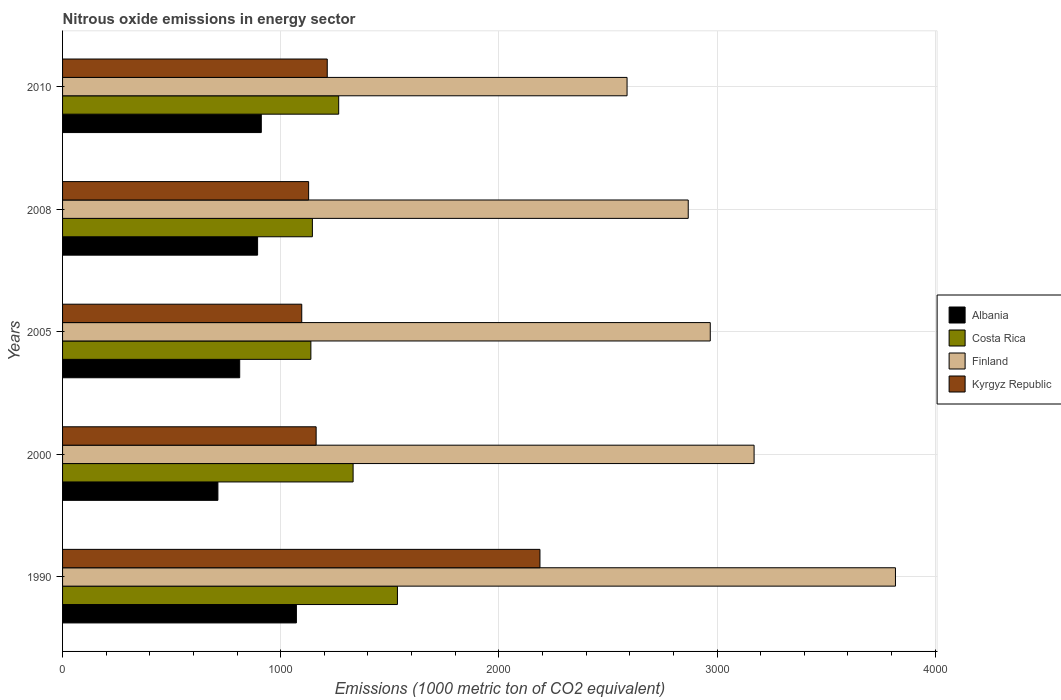How many groups of bars are there?
Provide a succinct answer. 5. How many bars are there on the 3rd tick from the bottom?
Offer a very short reply. 4. What is the amount of nitrous oxide emitted in Finland in 2010?
Ensure brevity in your answer.  2587.6. Across all years, what is the maximum amount of nitrous oxide emitted in Finland?
Your response must be concise. 3817.9. Across all years, what is the minimum amount of nitrous oxide emitted in Costa Rica?
Give a very brief answer. 1138.2. What is the total amount of nitrous oxide emitted in Albania in the graph?
Your response must be concise. 4401. What is the difference between the amount of nitrous oxide emitted in Albania in 2008 and that in 2010?
Provide a succinct answer. -17. What is the difference between the amount of nitrous oxide emitted in Finland in 2010 and the amount of nitrous oxide emitted in Kyrgyz Republic in 2005?
Offer a terse response. 1491.2. What is the average amount of nitrous oxide emitted in Albania per year?
Offer a very short reply. 880.2. In the year 2008, what is the difference between the amount of nitrous oxide emitted in Finland and amount of nitrous oxide emitted in Kyrgyz Republic?
Your response must be concise. 1740.1. In how many years, is the amount of nitrous oxide emitted in Kyrgyz Republic greater than 2000 1000 metric ton?
Your response must be concise. 1. What is the ratio of the amount of nitrous oxide emitted in Finland in 1990 to that in 2010?
Your answer should be very brief. 1.48. Is the amount of nitrous oxide emitted in Kyrgyz Republic in 2005 less than that in 2010?
Offer a very short reply. Yes. Is the difference between the amount of nitrous oxide emitted in Finland in 1990 and 2008 greater than the difference between the amount of nitrous oxide emitted in Kyrgyz Republic in 1990 and 2008?
Your response must be concise. No. What is the difference between the highest and the second highest amount of nitrous oxide emitted in Kyrgyz Republic?
Your response must be concise. 975. What is the difference between the highest and the lowest amount of nitrous oxide emitted in Albania?
Give a very brief answer. 359.8. In how many years, is the amount of nitrous oxide emitted in Finland greater than the average amount of nitrous oxide emitted in Finland taken over all years?
Offer a terse response. 2. Is it the case that in every year, the sum of the amount of nitrous oxide emitted in Costa Rica and amount of nitrous oxide emitted in Finland is greater than the sum of amount of nitrous oxide emitted in Kyrgyz Republic and amount of nitrous oxide emitted in Albania?
Offer a very short reply. Yes. What does the 2nd bar from the bottom in 2008 represents?
Provide a succinct answer. Costa Rica. How many bars are there?
Your answer should be compact. 20. Are all the bars in the graph horizontal?
Offer a very short reply. Yes. How many years are there in the graph?
Provide a short and direct response. 5. What is the difference between two consecutive major ticks on the X-axis?
Provide a succinct answer. 1000. Are the values on the major ticks of X-axis written in scientific E-notation?
Your response must be concise. No. Where does the legend appear in the graph?
Offer a very short reply. Center right. What is the title of the graph?
Offer a terse response. Nitrous oxide emissions in energy sector. What is the label or title of the X-axis?
Your response must be concise. Emissions (1000 metric ton of CO2 equivalent). What is the label or title of the Y-axis?
Your answer should be compact. Years. What is the Emissions (1000 metric ton of CO2 equivalent) of Albania in 1990?
Offer a terse response. 1071.9. What is the Emissions (1000 metric ton of CO2 equivalent) in Costa Rica in 1990?
Your response must be concise. 1535. What is the Emissions (1000 metric ton of CO2 equivalent) in Finland in 1990?
Provide a succinct answer. 3817.9. What is the Emissions (1000 metric ton of CO2 equivalent) of Kyrgyz Republic in 1990?
Your answer should be compact. 2188.3. What is the Emissions (1000 metric ton of CO2 equivalent) of Albania in 2000?
Ensure brevity in your answer.  712.1. What is the Emissions (1000 metric ton of CO2 equivalent) in Costa Rica in 2000?
Provide a short and direct response. 1331.8. What is the Emissions (1000 metric ton of CO2 equivalent) in Finland in 2000?
Your answer should be very brief. 3169.9. What is the Emissions (1000 metric ton of CO2 equivalent) of Kyrgyz Republic in 2000?
Provide a succinct answer. 1162.4. What is the Emissions (1000 metric ton of CO2 equivalent) in Albania in 2005?
Keep it short and to the point. 812. What is the Emissions (1000 metric ton of CO2 equivalent) in Costa Rica in 2005?
Give a very brief answer. 1138.2. What is the Emissions (1000 metric ton of CO2 equivalent) in Finland in 2005?
Give a very brief answer. 2969. What is the Emissions (1000 metric ton of CO2 equivalent) in Kyrgyz Republic in 2005?
Your answer should be compact. 1096.4. What is the Emissions (1000 metric ton of CO2 equivalent) in Albania in 2008?
Make the answer very short. 894. What is the Emissions (1000 metric ton of CO2 equivalent) of Costa Rica in 2008?
Give a very brief answer. 1145.2. What is the Emissions (1000 metric ton of CO2 equivalent) in Finland in 2008?
Your answer should be very brief. 2868. What is the Emissions (1000 metric ton of CO2 equivalent) in Kyrgyz Republic in 2008?
Provide a succinct answer. 1127.9. What is the Emissions (1000 metric ton of CO2 equivalent) of Albania in 2010?
Make the answer very short. 911. What is the Emissions (1000 metric ton of CO2 equivalent) in Costa Rica in 2010?
Your answer should be very brief. 1265.7. What is the Emissions (1000 metric ton of CO2 equivalent) of Finland in 2010?
Offer a terse response. 2587.6. What is the Emissions (1000 metric ton of CO2 equivalent) in Kyrgyz Republic in 2010?
Offer a terse response. 1213.3. Across all years, what is the maximum Emissions (1000 metric ton of CO2 equivalent) of Albania?
Provide a short and direct response. 1071.9. Across all years, what is the maximum Emissions (1000 metric ton of CO2 equivalent) in Costa Rica?
Ensure brevity in your answer.  1535. Across all years, what is the maximum Emissions (1000 metric ton of CO2 equivalent) in Finland?
Provide a succinct answer. 3817.9. Across all years, what is the maximum Emissions (1000 metric ton of CO2 equivalent) of Kyrgyz Republic?
Your answer should be compact. 2188.3. Across all years, what is the minimum Emissions (1000 metric ton of CO2 equivalent) of Albania?
Give a very brief answer. 712.1. Across all years, what is the minimum Emissions (1000 metric ton of CO2 equivalent) in Costa Rica?
Keep it short and to the point. 1138.2. Across all years, what is the minimum Emissions (1000 metric ton of CO2 equivalent) of Finland?
Offer a very short reply. 2587.6. Across all years, what is the minimum Emissions (1000 metric ton of CO2 equivalent) of Kyrgyz Republic?
Your answer should be very brief. 1096.4. What is the total Emissions (1000 metric ton of CO2 equivalent) in Albania in the graph?
Offer a terse response. 4401. What is the total Emissions (1000 metric ton of CO2 equivalent) in Costa Rica in the graph?
Provide a succinct answer. 6415.9. What is the total Emissions (1000 metric ton of CO2 equivalent) of Finland in the graph?
Your answer should be compact. 1.54e+04. What is the total Emissions (1000 metric ton of CO2 equivalent) of Kyrgyz Republic in the graph?
Your answer should be compact. 6788.3. What is the difference between the Emissions (1000 metric ton of CO2 equivalent) in Albania in 1990 and that in 2000?
Provide a succinct answer. 359.8. What is the difference between the Emissions (1000 metric ton of CO2 equivalent) of Costa Rica in 1990 and that in 2000?
Offer a terse response. 203.2. What is the difference between the Emissions (1000 metric ton of CO2 equivalent) of Finland in 1990 and that in 2000?
Provide a short and direct response. 648. What is the difference between the Emissions (1000 metric ton of CO2 equivalent) in Kyrgyz Republic in 1990 and that in 2000?
Ensure brevity in your answer.  1025.9. What is the difference between the Emissions (1000 metric ton of CO2 equivalent) of Albania in 1990 and that in 2005?
Give a very brief answer. 259.9. What is the difference between the Emissions (1000 metric ton of CO2 equivalent) in Costa Rica in 1990 and that in 2005?
Keep it short and to the point. 396.8. What is the difference between the Emissions (1000 metric ton of CO2 equivalent) in Finland in 1990 and that in 2005?
Your answer should be very brief. 848.9. What is the difference between the Emissions (1000 metric ton of CO2 equivalent) in Kyrgyz Republic in 1990 and that in 2005?
Keep it short and to the point. 1091.9. What is the difference between the Emissions (1000 metric ton of CO2 equivalent) in Albania in 1990 and that in 2008?
Give a very brief answer. 177.9. What is the difference between the Emissions (1000 metric ton of CO2 equivalent) in Costa Rica in 1990 and that in 2008?
Offer a terse response. 389.8. What is the difference between the Emissions (1000 metric ton of CO2 equivalent) of Finland in 1990 and that in 2008?
Keep it short and to the point. 949.9. What is the difference between the Emissions (1000 metric ton of CO2 equivalent) of Kyrgyz Republic in 1990 and that in 2008?
Give a very brief answer. 1060.4. What is the difference between the Emissions (1000 metric ton of CO2 equivalent) in Albania in 1990 and that in 2010?
Give a very brief answer. 160.9. What is the difference between the Emissions (1000 metric ton of CO2 equivalent) of Costa Rica in 1990 and that in 2010?
Keep it short and to the point. 269.3. What is the difference between the Emissions (1000 metric ton of CO2 equivalent) in Finland in 1990 and that in 2010?
Offer a terse response. 1230.3. What is the difference between the Emissions (1000 metric ton of CO2 equivalent) in Kyrgyz Republic in 1990 and that in 2010?
Make the answer very short. 975. What is the difference between the Emissions (1000 metric ton of CO2 equivalent) of Albania in 2000 and that in 2005?
Your answer should be very brief. -99.9. What is the difference between the Emissions (1000 metric ton of CO2 equivalent) of Costa Rica in 2000 and that in 2005?
Give a very brief answer. 193.6. What is the difference between the Emissions (1000 metric ton of CO2 equivalent) in Finland in 2000 and that in 2005?
Keep it short and to the point. 200.9. What is the difference between the Emissions (1000 metric ton of CO2 equivalent) in Albania in 2000 and that in 2008?
Ensure brevity in your answer.  -181.9. What is the difference between the Emissions (1000 metric ton of CO2 equivalent) of Costa Rica in 2000 and that in 2008?
Offer a very short reply. 186.6. What is the difference between the Emissions (1000 metric ton of CO2 equivalent) of Finland in 2000 and that in 2008?
Your answer should be compact. 301.9. What is the difference between the Emissions (1000 metric ton of CO2 equivalent) in Kyrgyz Republic in 2000 and that in 2008?
Offer a terse response. 34.5. What is the difference between the Emissions (1000 metric ton of CO2 equivalent) in Albania in 2000 and that in 2010?
Your answer should be compact. -198.9. What is the difference between the Emissions (1000 metric ton of CO2 equivalent) of Costa Rica in 2000 and that in 2010?
Your response must be concise. 66.1. What is the difference between the Emissions (1000 metric ton of CO2 equivalent) of Finland in 2000 and that in 2010?
Your answer should be compact. 582.3. What is the difference between the Emissions (1000 metric ton of CO2 equivalent) of Kyrgyz Republic in 2000 and that in 2010?
Offer a very short reply. -50.9. What is the difference between the Emissions (1000 metric ton of CO2 equivalent) of Albania in 2005 and that in 2008?
Your response must be concise. -82. What is the difference between the Emissions (1000 metric ton of CO2 equivalent) of Finland in 2005 and that in 2008?
Your answer should be compact. 101. What is the difference between the Emissions (1000 metric ton of CO2 equivalent) of Kyrgyz Republic in 2005 and that in 2008?
Ensure brevity in your answer.  -31.5. What is the difference between the Emissions (1000 metric ton of CO2 equivalent) of Albania in 2005 and that in 2010?
Give a very brief answer. -99. What is the difference between the Emissions (1000 metric ton of CO2 equivalent) in Costa Rica in 2005 and that in 2010?
Your answer should be compact. -127.5. What is the difference between the Emissions (1000 metric ton of CO2 equivalent) of Finland in 2005 and that in 2010?
Ensure brevity in your answer.  381.4. What is the difference between the Emissions (1000 metric ton of CO2 equivalent) in Kyrgyz Republic in 2005 and that in 2010?
Give a very brief answer. -116.9. What is the difference between the Emissions (1000 metric ton of CO2 equivalent) in Costa Rica in 2008 and that in 2010?
Provide a succinct answer. -120.5. What is the difference between the Emissions (1000 metric ton of CO2 equivalent) in Finland in 2008 and that in 2010?
Offer a very short reply. 280.4. What is the difference between the Emissions (1000 metric ton of CO2 equivalent) of Kyrgyz Republic in 2008 and that in 2010?
Offer a very short reply. -85.4. What is the difference between the Emissions (1000 metric ton of CO2 equivalent) of Albania in 1990 and the Emissions (1000 metric ton of CO2 equivalent) of Costa Rica in 2000?
Provide a short and direct response. -259.9. What is the difference between the Emissions (1000 metric ton of CO2 equivalent) in Albania in 1990 and the Emissions (1000 metric ton of CO2 equivalent) in Finland in 2000?
Keep it short and to the point. -2098. What is the difference between the Emissions (1000 metric ton of CO2 equivalent) in Albania in 1990 and the Emissions (1000 metric ton of CO2 equivalent) in Kyrgyz Republic in 2000?
Your response must be concise. -90.5. What is the difference between the Emissions (1000 metric ton of CO2 equivalent) of Costa Rica in 1990 and the Emissions (1000 metric ton of CO2 equivalent) of Finland in 2000?
Your answer should be very brief. -1634.9. What is the difference between the Emissions (1000 metric ton of CO2 equivalent) of Costa Rica in 1990 and the Emissions (1000 metric ton of CO2 equivalent) of Kyrgyz Republic in 2000?
Your response must be concise. 372.6. What is the difference between the Emissions (1000 metric ton of CO2 equivalent) of Finland in 1990 and the Emissions (1000 metric ton of CO2 equivalent) of Kyrgyz Republic in 2000?
Provide a succinct answer. 2655.5. What is the difference between the Emissions (1000 metric ton of CO2 equivalent) of Albania in 1990 and the Emissions (1000 metric ton of CO2 equivalent) of Costa Rica in 2005?
Offer a terse response. -66.3. What is the difference between the Emissions (1000 metric ton of CO2 equivalent) of Albania in 1990 and the Emissions (1000 metric ton of CO2 equivalent) of Finland in 2005?
Give a very brief answer. -1897.1. What is the difference between the Emissions (1000 metric ton of CO2 equivalent) in Albania in 1990 and the Emissions (1000 metric ton of CO2 equivalent) in Kyrgyz Republic in 2005?
Offer a terse response. -24.5. What is the difference between the Emissions (1000 metric ton of CO2 equivalent) in Costa Rica in 1990 and the Emissions (1000 metric ton of CO2 equivalent) in Finland in 2005?
Your answer should be very brief. -1434. What is the difference between the Emissions (1000 metric ton of CO2 equivalent) in Costa Rica in 1990 and the Emissions (1000 metric ton of CO2 equivalent) in Kyrgyz Republic in 2005?
Your response must be concise. 438.6. What is the difference between the Emissions (1000 metric ton of CO2 equivalent) in Finland in 1990 and the Emissions (1000 metric ton of CO2 equivalent) in Kyrgyz Republic in 2005?
Your response must be concise. 2721.5. What is the difference between the Emissions (1000 metric ton of CO2 equivalent) in Albania in 1990 and the Emissions (1000 metric ton of CO2 equivalent) in Costa Rica in 2008?
Offer a terse response. -73.3. What is the difference between the Emissions (1000 metric ton of CO2 equivalent) in Albania in 1990 and the Emissions (1000 metric ton of CO2 equivalent) in Finland in 2008?
Your response must be concise. -1796.1. What is the difference between the Emissions (1000 metric ton of CO2 equivalent) of Albania in 1990 and the Emissions (1000 metric ton of CO2 equivalent) of Kyrgyz Republic in 2008?
Offer a very short reply. -56. What is the difference between the Emissions (1000 metric ton of CO2 equivalent) of Costa Rica in 1990 and the Emissions (1000 metric ton of CO2 equivalent) of Finland in 2008?
Provide a succinct answer. -1333. What is the difference between the Emissions (1000 metric ton of CO2 equivalent) of Costa Rica in 1990 and the Emissions (1000 metric ton of CO2 equivalent) of Kyrgyz Republic in 2008?
Make the answer very short. 407.1. What is the difference between the Emissions (1000 metric ton of CO2 equivalent) in Finland in 1990 and the Emissions (1000 metric ton of CO2 equivalent) in Kyrgyz Republic in 2008?
Ensure brevity in your answer.  2690. What is the difference between the Emissions (1000 metric ton of CO2 equivalent) of Albania in 1990 and the Emissions (1000 metric ton of CO2 equivalent) of Costa Rica in 2010?
Offer a very short reply. -193.8. What is the difference between the Emissions (1000 metric ton of CO2 equivalent) in Albania in 1990 and the Emissions (1000 metric ton of CO2 equivalent) in Finland in 2010?
Provide a succinct answer. -1515.7. What is the difference between the Emissions (1000 metric ton of CO2 equivalent) of Albania in 1990 and the Emissions (1000 metric ton of CO2 equivalent) of Kyrgyz Republic in 2010?
Keep it short and to the point. -141.4. What is the difference between the Emissions (1000 metric ton of CO2 equivalent) in Costa Rica in 1990 and the Emissions (1000 metric ton of CO2 equivalent) in Finland in 2010?
Your answer should be compact. -1052.6. What is the difference between the Emissions (1000 metric ton of CO2 equivalent) in Costa Rica in 1990 and the Emissions (1000 metric ton of CO2 equivalent) in Kyrgyz Republic in 2010?
Offer a very short reply. 321.7. What is the difference between the Emissions (1000 metric ton of CO2 equivalent) of Finland in 1990 and the Emissions (1000 metric ton of CO2 equivalent) of Kyrgyz Republic in 2010?
Your answer should be compact. 2604.6. What is the difference between the Emissions (1000 metric ton of CO2 equivalent) in Albania in 2000 and the Emissions (1000 metric ton of CO2 equivalent) in Costa Rica in 2005?
Your answer should be compact. -426.1. What is the difference between the Emissions (1000 metric ton of CO2 equivalent) in Albania in 2000 and the Emissions (1000 metric ton of CO2 equivalent) in Finland in 2005?
Offer a terse response. -2256.9. What is the difference between the Emissions (1000 metric ton of CO2 equivalent) in Albania in 2000 and the Emissions (1000 metric ton of CO2 equivalent) in Kyrgyz Republic in 2005?
Provide a short and direct response. -384.3. What is the difference between the Emissions (1000 metric ton of CO2 equivalent) in Costa Rica in 2000 and the Emissions (1000 metric ton of CO2 equivalent) in Finland in 2005?
Provide a short and direct response. -1637.2. What is the difference between the Emissions (1000 metric ton of CO2 equivalent) in Costa Rica in 2000 and the Emissions (1000 metric ton of CO2 equivalent) in Kyrgyz Republic in 2005?
Provide a succinct answer. 235.4. What is the difference between the Emissions (1000 metric ton of CO2 equivalent) in Finland in 2000 and the Emissions (1000 metric ton of CO2 equivalent) in Kyrgyz Republic in 2005?
Provide a succinct answer. 2073.5. What is the difference between the Emissions (1000 metric ton of CO2 equivalent) in Albania in 2000 and the Emissions (1000 metric ton of CO2 equivalent) in Costa Rica in 2008?
Keep it short and to the point. -433.1. What is the difference between the Emissions (1000 metric ton of CO2 equivalent) in Albania in 2000 and the Emissions (1000 metric ton of CO2 equivalent) in Finland in 2008?
Offer a terse response. -2155.9. What is the difference between the Emissions (1000 metric ton of CO2 equivalent) in Albania in 2000 and the Emissions (1000 metric ton of CO2 equivalent) in Kyrgyz Republic in 2008?
Offer a terse response. -415.8. What is the difference between the Emissions (1000 metric ton of CO2 equivalent) of Costa Rica in 2000 and the Emissions (1000 metric ton of CO2 equivalent) of Finland in 2008?
Give a very brief answer. -1536.2. What is the difference between the Emissions (1000 metric ton of CO2 equivalent) in Costa Rica in 2000 and the Emissions (1000 metric ton of CO2 equivalent) in Kyrgyz Republic in 2008?
Provide a succinct answer. 203.9. What is the difference between the Emissions (1000 metric ton of CO2 equivalent) of Finland in 2000 and the Emissions (1000 metric ton of CO2 equivalent) of Kyrgyz Republic in 2008?
Your response must be concise. 2042. What is the difference between the Emissions (1000 metric ton of CO2 equivalent) of Albania in 2000 and the Emissions (1000 metric ton of CO2 equivalent) of Costa Rica in 2010?
Provide a short and direct response. -553.6. What is the difference between the Emissions (1000 metric ton of CO2 equivalent) of Albania in 2000 and the Emissions (1000 metric ton of CO2 equivalent) of Finland in 2010?
Offer a terse response. -1875.5. What is the difference between the Emissions (1000 metric ton of CO2 equivalent) in Albania in 2000 and the Emissions (1000 metric ton of CO2 equivalent) in Kyrgyz Republic in 2010?
Ensure brevity in your answer.  -501.2. What is the difference between the Emissions (1000 metric ton of CO2 equivalent) in Costa Rica in 2000 and the Emissions (1000 metric ton of CO2 equivalent) in Finland in 2010?
Give a very brief answer. -1255.8. What is the difference between the Emissions (1000 metric ton of CO2 equivalent) in Costa Rica in 2000 and the Emissions (1000 metric ton of CO2 equivalent) in Kyrgyz Republic in 2010?
Make the answer very short. 118.5. What is the difference between the Emissions (1000 metric ton of CO2 equivalent) in Finland in 2000 and the Emissions (1000 metric ton of CO2 equivalent) in Kyrgyz Republic in 2010?
Keep it short and to the point. 1956.6. What is the difference between the Emissions (1000 metric ton of CO2 equivalent) in Albania in 2005 and the Emissions (1000 metric ton of CO2 equivalent) in Costa Rica in 2008?
Your answer should be compact. -333.2. What is the difference between the Emissions (1000 metric ton of CO2 equivalent) in Albania in 2005 and the Emissions (1000 metric ton of CO2 equivalent) in Finland in 2008?
Keep it short and to the point. -2056. What is the difference between the Emissions (1000 metric ton of CO2 equivalent) of Albania in 2005 and the Emissions (1000 metric ton of CO2 equivalent) of Kyrgyz Republic in 2008?
Make the answer very short. -315.9. What is the difference between the Emissions (1000 metric ton of CO2 equivalent) of Costa Rica in 2005 and the Emissions (1000 metric ton of CO2 equivalent) of Finland in 2008?
Offer a terse response. -1729.8. What is the difference between the Emissions (1000 metric ton of CO2 equivalent) in Costa Rica in 2005 and the Emissions (1000 metric ton of CO2 equivalent) in Kyrgyz Republic in 2008?
Your response must be concise. 10.3. What is the difference between the Emissions (1000 metric ton of CO2 equivalent) in Finland in 2005 and the Emissions (1000 metric ton of CO2 equivalent) in Kyrgyz Republic in 2008?
Ensure brevity in your answer.  1841.1. What is the difference between the Emissions (1000 metric ton of CO2 equivalent) of Albania in 2005 and the Emissions (1000 metric ton of CO2 equivalent) of Costa Rica in 2010?
Offer a terse response. -453.7. What is the difference between the Emissions (1000 metric ton of CO2 equivalent) of Albania in 2005 and the Emissions (1000 metric ton of CO2 equivalent) of Finland in 2010?
Give a very brief answer. -1775.6. What is the difference between the Emissions (1000 metric ton of CO2 equivalent) in Albania in 2005 and the Emissions (1000 metric ton of CO2 equivalent) in Kyrgyz Republic in 2010?
Make the answer very short. -401.3. What is the difference between the Emissions (1000 metric ton of CO2 equivalent) of Costa Rica in 2005 and the Emissions (1000 metric ton of CO2 equivalent) of Finland in 2010?
Your answer should be very brief. -1449.4. What is the difference between the Emissions (1000 metric ton of CO2 equivalent) of Costa Rica in 2005 and the Emissions (1000 metric ton of CO2 equivalent) of Kyrgyz Republic in 2010?
Ensure brevity in your answer.  -75.1. What is the difference between the Emissions (1000 metric ton of CO2 equivalent) of Finland in 2005 and the Emissions (1000 metric ton of CO2 equivalent) of Kyrgyz Republic in 2010?
Your response must be concise. 1755.7. What is the difference between the Emissions (1000 metric ton of CO2 equivalent) in Albania in 2008 and the Emissions (1000 metric ton of CO2 equivalent) in Costa Rica in 2010?
Your response must be concise. -371.7. What is the difference between the Emissions (1000 metric ton of CO2 equivalent) of Albania in 2008 and the Emissions (1000 metric ton of CO2 equivalent) of Finland in 2010?
Give a very brief answer. -1693.6. What is the difference between the Emissions (1000 metric ton of CO2 equivalent) of Albania in 2008 and the Emissions (1000 metric ton of CO2 equivalent) of Kyrgyz Republic in 2010?
Keep it short and to the point. -319.3. What is the difference between the Emissions (1000 metric ton of CO2 equivalent) in Costa Rica in 2008 and the Emissions (1000 metric ton of CO2 equivalent) in Finland in 2010?
Ensure brevity in your answer.  -1442.4. What is the difference between the Emissions (1000 metric ton of CO2 equivalent) in Costa Rica in 2008 and the Emissions (1000 metric ton of CO2 equivalent) in Kyrgyz Republic in 2010?
Your answer should be very brief. -68.1. What is the difference between the Emissions (1000 metric ton of CO2 equivalent) in Finland in 2008 and the Emissions (1000 metric ton of CO2 equivalent) in Kyrgyz Republic in 2010?
Give a very brief answer. 1654.7. What is the average Emissions (1000 metric ton of CO2 equivalent) in Albania per year?
Ensure brevity in your answer.  880.2. What is the average Emissions (1000 metric ton of CO2 equivalent) of Costa Rica per year?
Offer a terse response. 1283.18. What is the average Emissions (1000 metric ton of CO2 equivalent) of Finland per year?
Make the answer very short. 3082.48. What is the average Emissions (1000 metric ton of CO2 equivalent) of Kyrgyz Republic per year?
Keep it short and to the point. 1357.66. In the year 1990, what is the difference between the Emissions (1000 metric ton of CO2 equivalent) of Albania and Emissions (1000 metric ton of CO2 equivalent) of Costa Rica?
Offer a very short reply. -463.1. In the year 1990, what is the difference between the Emissions (1000 metric ton of CO2 equivalent) of Albania and Emissions (1000 metric ton of CO2 equivalent) of Finland?
Give a very brief answer. -2746. In the year 1990, what is the difference between the Emissions (1000 metric ton of CO2 equivalent) of Albania and Emissions (1000 metric ton of CO2 equivalent) of Kyrgyz Republic?
Offer a very short reply. -1116.4. In the year 1990, what is the difference between the Emissions (1000 metric ton of CO2 equivalent) of Costa Rica and Emissions (1000 metric ton of CO2 equivalent) of Finland?
Give a very brief answer. -2282.9. In the year 1990, what is the difference between the Emissions (1000 metric ton of CO2 equivalent) of Costa Rica and Emissions (1000 metric ton of CO2 equivalent) of Kyrgyz Republic?
Offer a terse response. -653.3. In the year 1990, what is the difference between the Emissions (1000 metric ton of CO2 equivalent) in Finland and Emissions (1000 metric ton of CO2 equivalent) in Kyrgyz Republic?
Give a very brief answer. 1629.6. In the year 2000, what is the difference between the Emissions (1000 metric ton of CO2 equivalent) in Albania and Emissions (1000 metric ton of CO2 equivalent) in Costa Rica?
Keep it short and to the point. -619.7. In the year 2000, what is the difference between the Emissions (1000 metric ton of CO2 equivalent) of Albania and Emissions (1000 metric ton of CO2 equivalent) of Finland?
Provide a short and direct response. -2457.8. In the year 2000, what is the difference between the Emissions (1000 metric ton of CO2 equivalent) of Albania and Emissions (1000 metric ton of CO2 equivalent) of Kyrgyz Republic?
Ensure brevity in your answer.  -450.3. In the year 2000, what is the difference between the Emissions (1000 metric ton of CO2 equivalent) of Costa Rica and Emissions (1000 metric ton of CO2 equivalent) of Finland?
Your response must be concise. -1838.1. In the year 2000, what is the difference between the Emissions (1000 metric ton of CO2 equivalent) of Costa Rica and Emissions (1000 metric ton of CO2 equivalent) of Kyrgyz Republic?
Your answer should be very brief. 169.4. In the year 2000, what is the difference between the Emissions (1000 metric ton of CO2 equivalent) of Finland and Emissions (1000 metric ton of CO2 equivalent) of Kyrgyz Republic?
Keep it short and to the point. 2007.5. In the year 2005, what is the difference between the Emissions (1000 metric ton of CO2 equivalent) in Albania and Emissions (1000 metric ton of CO2 equivalent) in Costa Rica?
Provide a succinct answer. -326.2. In the year 2005, what is the difference between the Emissions (1000 metric ton of CO2 equivalent) in Albania and Emissions (1000 metric ton of CO2 equivalent) in Finland?
Offer a very short reply. -2157. In the year 2005, what is the difference between the Emissions (1000 metric ton of CO2 equivalent) of Albania and Emissions (1000 metric ton of CO2 equivalent) of Kyrgyz Republic?
Provide a succinct answer. -284.4. In the year 2005, what is the difference between the Emissions (1000 metric ton of CO2 equivalent) of Costa Rica and Emissions (1000 metric ton of CO2 equivalent) of Finland?
Provide a succinct answer. -1830.8. In the year 2005, what is the difference between the Emissions (1000 metric ton of CO2 equivalent) in Costa Rica and Emissions (1000 metric ton of CO2 equivalent) in Kyrgyz Republic?
Provide a succinct answer. 41.8. In the year 2005, what is the difference between the Emissions (1000 metric ton of CO2 equivalent) in Finland and Emissions (1000 metric ton of CO2 equivalent) in Kyrgyz Republic?
Provide a succinct answer. 1872.6. In the year 2008, what is the difference between the Emissions (1000 metric ton of CO2 equivalent) of Albania and Emissions (1000 metric ton of CO2 equivalent) of Costa Rica?
Offer a terse response. -251.2. In the year 2008, what is the difference between the Emissions (1000 metric ton of CO2 equivalent) of Albania and Emissions (1000 metric ton of CO2 equivalent) of Finland?
Your answer should be compact. -1974. In the year 2008, what is the difference between the Emissions (1000 metric ton of CO2 equivalent) of Albania and Emissions (1000 metric ton of CO2 equivalent) of Kyrgyz Republic?
Your response must be concise. -233.9. In the year 2008, what is the difference between the Emissions (1000 metric ton of CO2 equivalent) of Costa Rica and Emissions (1000 metric ton of CO2 equivalent) of Finland?
Give a very brief answer. -1722.8. In the year 2008, what is the difference between the Emissions (1000 metric ton of CO2 equivalent) of Costa Rica and Emissions (1000 metric ton of CO2 equivalent) of Kyrgyz Republic?
Give a very brief answer. 17.3. In the year 2008, what is the difference between the Emissions (1000 metric ton of CO2 equivalent) in Finland and Emissions (1000 metric ton of CO2 equivalent) in Kyrgyz Republic?
Your answer should be compact. 1740.1. In the year 2010, what is the difference between the Emissions (1000 metric ton of CO2 equivalent) in Albania and Emissions (1000 metric ton of CO2 equivalent) in Costa Rica?
Provide a succinct answer. -354.7. In the year 2010, what is the difference between the Emissions (1000 metric ton of CO2 equivalent) in Albania and Emissions (1000 metric ton of CO2 equivalent) in Finland?
Your answer should be compact. -1676.6. In the year 2010, what is the difference between the Emissions (1000 metric ton of CO2 equivalent) in Albania and Emissions (1000 metric ton of CO2 equivalent) in Kyrgyz Republic?
Offer a terse response. -302.3. In the year 2010, what is the difference between the Emissions (1000 metric ton of CO2 equivalent) of Costa Rica and Emissions (1000 metric ton of CO2 equivalent) of Finland?
Provide a short and direct response. -1321.9. In the year 2010, what is the difference between the Emissions (1000 metric ton of CO2 equivalent) in Costa Rica and Emissions (1000 metric ton of CO2 equivalent) in Kyrgyz Republic?
Your answer should be very brief. 52.4. In the year 2010, what is the difference between the Emissions (1000 metric ton of CO2 equivalent) of Finland and Emissions (1000 metric ton of CO2 equivalent) of Kyrgyz Republic?
Ensure brevity in your answer.  1374.3. What is the ratio of the Emissions (1000 metric ton of CO2 equivalent) in Albania in 1990 to that in 2000?
Provide a short and direct response. 1.51. What is the ratio of the Emissions (1000 metric ton of CO2 equivalent) of Costa Rica in 1990 to that in 2000?
Make the answer very short. 1.15. What is the ratio of the Emissions (1000 metric ton of CO2 equivalent) in Finland in 1990 to that in 2000?
Your answer should be very brief. 1.2. What is the ratio of the Emissions (1000 metric ton of CO2 equivalent) in Kyrgyz Republic in 1990 to that in 2000?
Make the answer very short. 1.88. What is the ratio of the Emissions (1000 metric ton of CO2 equivalent) of Albania in 1990 to that in 2005?
Provide a succinct answer. 1.32. What is the ratio of the Emissions (1000 metric ton of CO2 equivalent) in Costa Rica in 1990 to that in 2005?
Your response must be concise. 1.35. What is the ratio of the Emissions (1000 metric ton of CO2 equivalent) of Finland in 1990 to that in 2005?
Your answer should be very brief. 1.29. What is the ratio of the Emissions (1000 metric ton of CO2 equivalent) of Kyrgyz Republic in 1990 to that in 2005?
Ensure brevity in your answer.  2. What is the ratio of the Emissions (1000 metric ton of CO2 equivalent) of Albania in 1990 to that in 2008?
Keep it short and to the point. 1.2. What is the ratio of the Emissions (1000 metric ton of CO2 equivalent) of Costa Rica in 1990 to that in 2008?
Offer a very short reply. 1.34. What is the ratio of the Emissions (1000 metric ton of CO2 equivalent) of Finland in 1990 to that in 2008?
Offer a terse response. 1.33. What is the ratio of the Emissions (1000 metric ton of CO2 equivalent) in Kyrgyz Republic in 1990 to that in 2008?
Provide a short and direct response. 1.94. What is the ratio of the Emissions (1000 metric ton of CO2 equivalent) in Albania in 1990 to that in 2010?
Provide a succinct answer. 1.18. What is the ratio of the Emissions (1000 metric ton of CO2 equivalent) in Costa Rica in 1990 to that in 2010?
Provide a short and direct response. 1.21. What is the ratio of the Emissions (1000 metric ton of CO2 equivalent) of Finland in 1990 to that in 2010?
Your answer should be compact. 1.48. What is the ratio of the Emissions (1000 metric ton of CO2 equivalent) of Kyrgyz Republic in 1990 to that in 2010?
Your response must be concise. 1.8. What is the ratio of the Emissions (1000 metric ton of CO2 equivalent) of Albania in 2000 to that in 2005?
Your response must be concise. 0.88. What is the ratio of the Emissions (1000 metric ton of CO2 equivalent) in Costa Rica in 2000 to that in 2005?
Offer a terse response. 1.17. What is the ratio of the Emissions (1000 metric ton of CO2 equivalent) in Finland in 2000 to that in 2005?
Offer a very short reply. 1.07. What is the ratio of the Emissions (1000 metric ton of CO2 equivalent) in Kyrgyz Republic in 2000 to that in 2005?
Your answer should be very brief. 1.06. What is the ratio of the Emissions (1000 metric ton of CO2 equivalent) in Albania in 2000 to that in 2008?
Make the answer very short. 0.8. What is the ratio of the Emissions (1000 metric ton of CO2 equivalent) in Costa Rica in 2000 to that in 2008?
Your answer should be very brief. 1.16. What is the ratio of the Emissions (1000 metric ton of CO2 equivalent) of Finland in 2000 to that in 2008?
Your response must be concise. 1.11. What is the ratio of the Emissions (1000 metric ton of CO2 equivalent) in Kyrgyz Republic in 2000 to that in 2008?
Provide a succinct answer. 1.03. What is the ratio of the Emissions (1000 metric ton of CO2 equivalent) of Albania in 2000 to that in 2010?
Give a very brief answer. 0.78. What is the ratio of the Emissions (1000 metric ton of CO2 equivalent) in Costa Rica in 2000 to that in 2010?
Your answer should be compact. 1.05. What is the ratio of the Emissions (1000 metric ton of CO2 equivalent) in Finland in 2000 to that in 2010?
Offer a terse response. 1.23. What is the ratio of the Emissions (1000 metric ton of CO2 equivalent) of Kyrgyz Republic in 2000 to that in 2010?
Your response must be concise. 0.96. What is the ratio of the Emissions (1000 metric ton of CO2 equivalent) of Albania in 2005 to that in 2008?
Make the answer very short. 0.91. What is the ratio of the Emissions (1000 metric ton of CO2 equivalent) of Costa Rica in 2005 to that in 2008?
Your answer should be compact. 0.99. What is the ratio of the Emissions (1000 metric ton of CO2 equivalent) in Finland in 2005 to that in 2008?
Provide a short and direct response. 1.04. What is the ratio of the Emissions (1000 metric ton of CO2 equivalent) in Kyrgyz Republic in 2005 to that in 2008?
Provide a short and direct response. 0.97. What is the ratio of the Emissions (1000 metric ton of CO2 equivalent) in Albania in 2005 to that in 2010?
Give a very brief answer. 0.89. What is the ratio of the Emissions (1000 metric ton of CO2 equivalent) in Costa Rica in 2005 to that in 2010?
Ensure brevity in your answer.  0.9. What is the ratio of the Emissions (1000 metric ton of CO2 equivalent) of Finland in 2005 to that in 2010?
Make the answer very short. 1.15. What is the ratio of the Emissions (1000 metric ton of CO2 equivalent) of Kyrgyz Republic in 2005 to that in 2010?
Provide a short and direct response. 0.9. What is the ratio of the Emissions (1000 metric ton of CO2 equivalent) in Albania in 2008 to that in 2010?
Give a very brief answer. 0.98. What is the ratio of the Emissions (1000 metric ton of CO2 equivalent) in Costa Rica in 2008 to that in 2010?
Your answer should be compact. 0.9. What is the ratio of the Emissions (1000 metric ton of CO2 equivalent) in Finland in 2008 to that in 2010?
Your response must be concise. 1.11. What is the ratio of the Emissions (1000 metric ton of CO2 equivalent) in Kyrgyz Republic in 2008 to that in 2010?
Offer a very short reply. 0.93. What is the difference between the highest and the second highest Emissions (1000 metric ton of CO2 equivalent) of Albania?
Provide a short and direct response. 160.9. What is the difference between the highest and the second highest Emissions (1000 metric ton of CO2 equivalent) of Costa Rica?
Your answer should be very brief. 203.2. What is the difference between the highest and the second highest Emissions (1000 metric ton of CO2 equivalent) of Finland?
Provide a short and direct response. 648. What is the difference between the highest and the second highest Emissions (1000 metric ton of CO2 equivalent) in Kyrgyz Republic?
Keep it short and to the point. 975. What is the difference between the highest and the lowest Emissions (1000 metric ton of CO2 equivalent) in Albania?
Give a very brief answer. 359.8. What is the difference between the highest and the lowest Emissions (1000 metric ton of CO2 equivalent) of Costa Rica?
Make the answer very short. 396.8. What is the difference between the highest and the lowest Emissions (1000 metric ton of CO2 equivalent) in Finland?
Your answer should be very brief. 1230.3. What is the difference between the highest and the lowest Emissions (1000 metric ton of CO2 equivalent) of Kyrgyz Republic?
Give a very brief answer. 1091.9. 